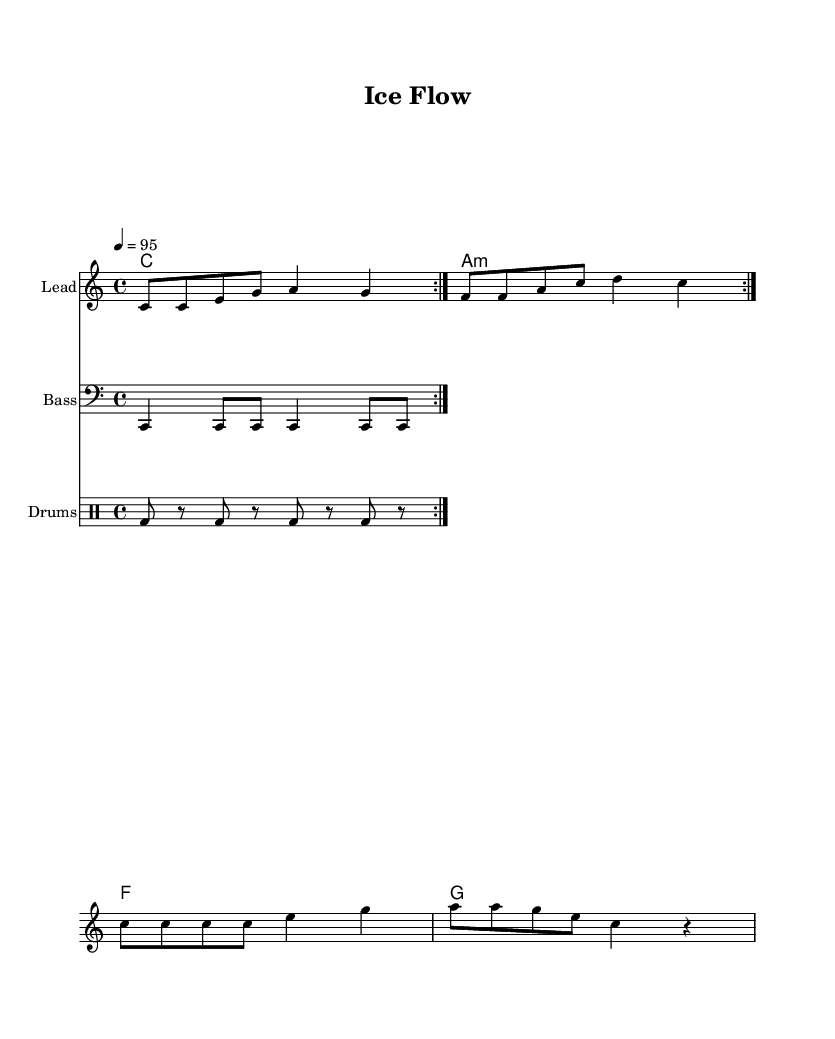What is the key signature of this music? The key signature indicated in the global section of the score shows a 'C major' key, which has no sharps or flats.
Answer: C major What is the time signature of this piece? The time signature is found in the global section and is written as '4/4', indicating four beats per measure.
Answer: 4/4 What is the tempo marking for this music? The tempo marking in the global section states '4 = 95', meaning there are 95 beats per minute.
Answer: 95 How many measures are repeated in the melody? In the melody section, the indication shows there is a 'repeat volta 2' which signifies two measures will be repeated twice.
Answer: 2 What kind of chord is used in the second measure? The second measure contains an a minor chord, indicated by 'a:m', which is the second harmony in the chord mode section.
Answer: a minor What is the instrument name for the lead part in this piece? The lead part is specified in the 'Staff' section where it's stated to be 'Lead', identifying the instrument for this staff.
Answer: Lead What is the pattern used for the bass? The bass pattern shown in the score represents a series of quarter notes and eighth notes. This pattern is used consistently across the sections.
Answer: Quarter notes and eighth notes 